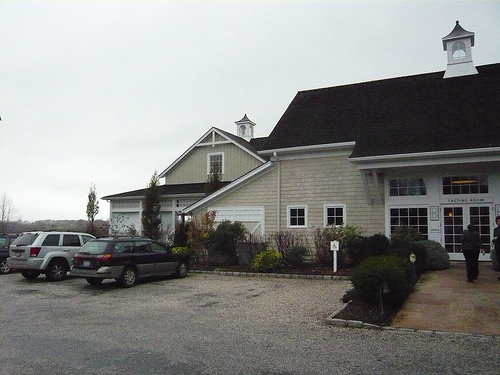<image>
Is the window under the roof? Yes. The window is positioned underneath the roof, with the roof above it in the vertical space. Is the car behind the suv? No. The car is not behind the suv. From this viewpoint, the car appears to be positioned elsewhere in the scene. 